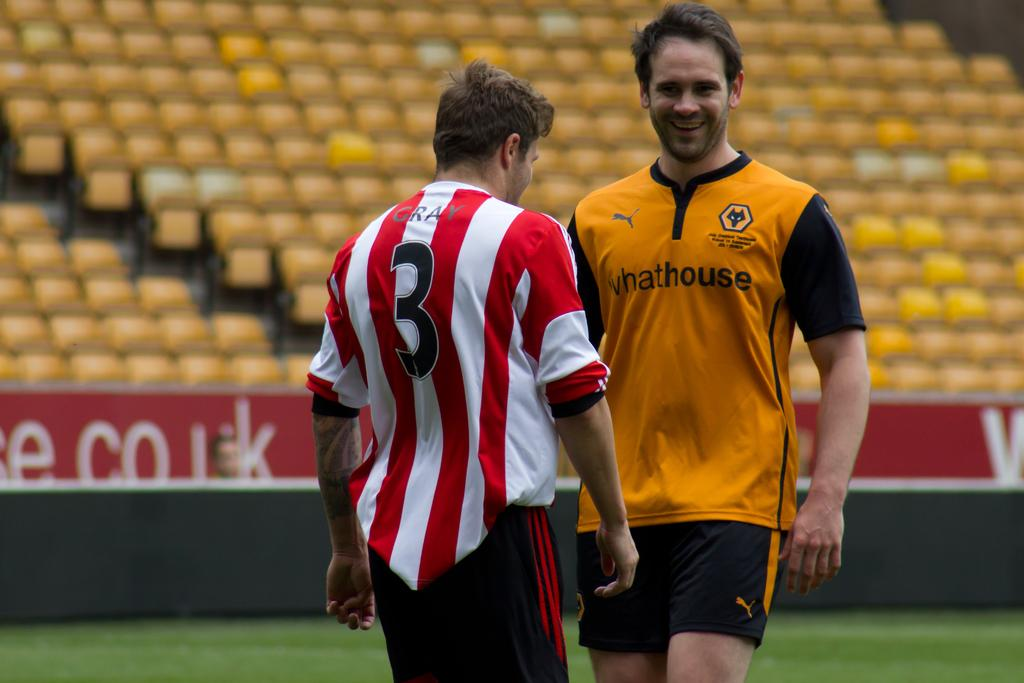Provide a one-sentence caption for the provided image. A man wears an orange shirt with whathouse on the front. 